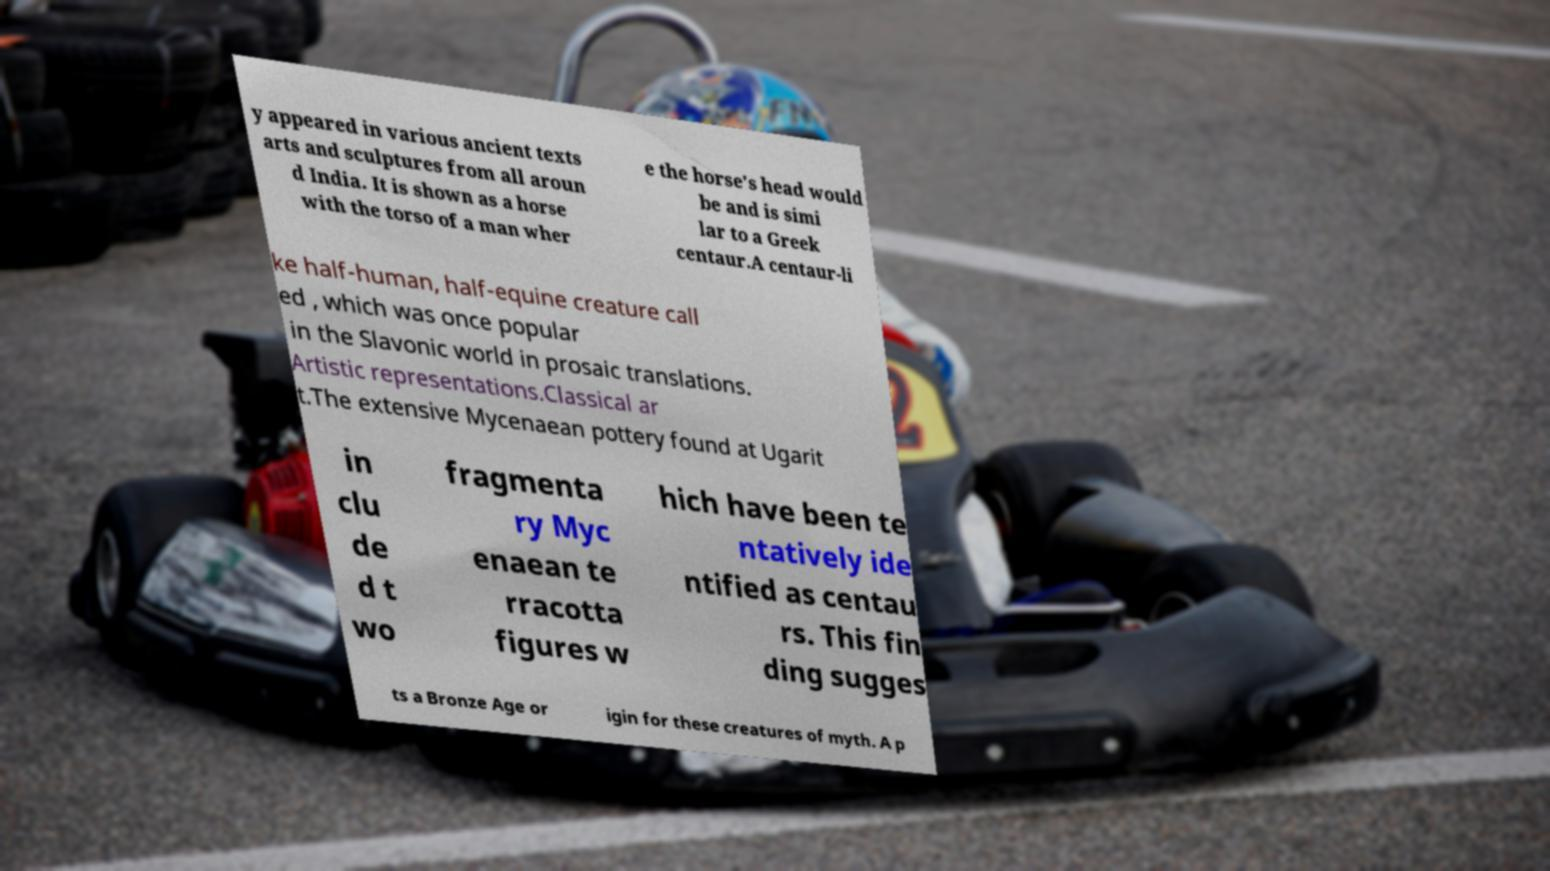Could you assist in decoding the text presented in this image and type it out clearly? y appeared in various ancient texts arts and sculptures from all aroun d India. It is shown as a horse with the torso of a man wher e the horse's head would be and is simi lar to a Greek centaur.A centaur-li ke half-human, half-equine creature call ed , which was once popular in the Slavonic world in prosaic translations. Artistic representations.Classical ar t.The extensive Mycenaean pottery found at Ugarit in clu de d t wo fragmenta ry Myc enaean te rracotta figures w hich have been te ntatively ide ntified as centau rs. This fin ding sugges ts a Bronze Age or igin for these creatures of myth. A p 